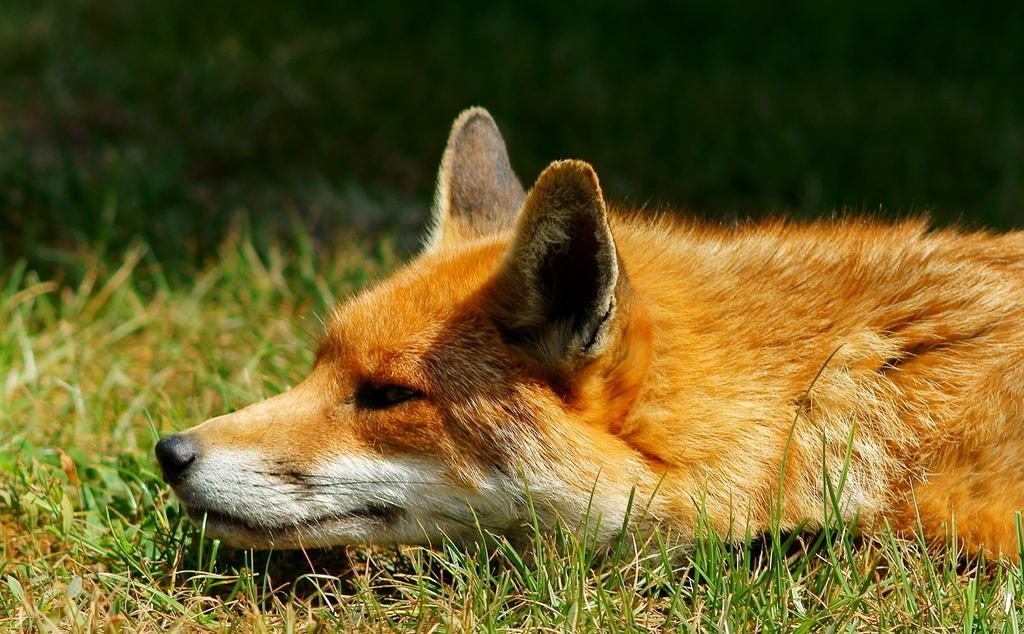How would you summarize this image in a sentence or two? There is a brown color dog, laying on the grass on the ground. The background is dark in color. 